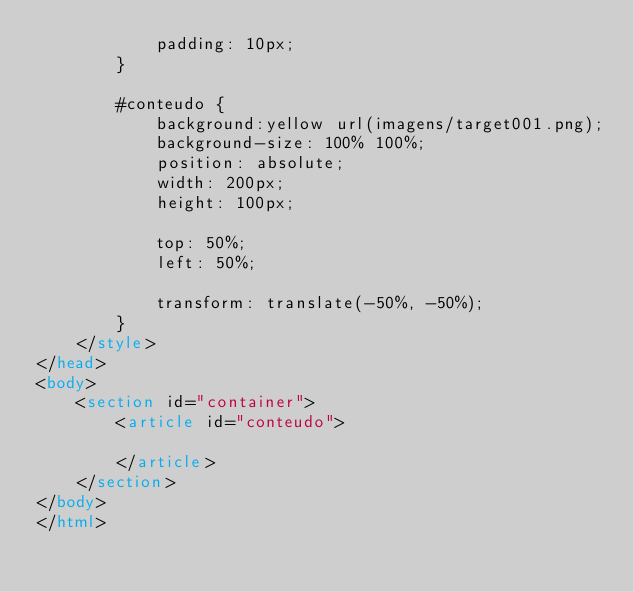<code> <loc_0><loc_0><loc_500><loc_500><_HTML_>            padding: 10px;
        }

        #conteudo {
            background:yellow url(imagens/target001.png);
            background-size: 100% 100%;
            position: absolute;
            width: 200px;
            height: 100px;

            top: 50%;
            left: 50%;

            transform: translate(-50%, -50%);
        }
    </style>
</head>
<body>
    <section id="container">
        <article id="conteudo">

        </article>
    </section>
</body>
</html></code> 